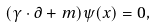<formula> <loc_0><loc_0><loc_500><loc_500>( \gamma \cdot \partial + m ) \psi ( x ) = 0 ,</formula> 